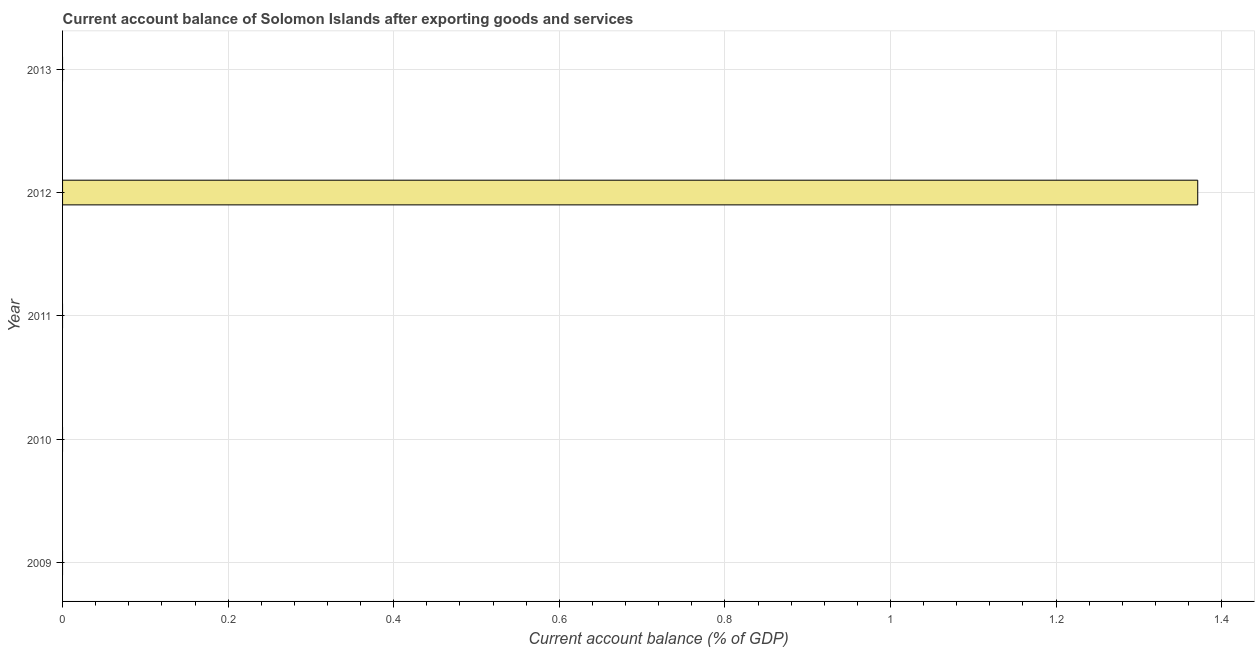Does the graph contain any zero values?
Provide a short and direct response. Yes. Does the graph contain grids?
Provide a succinct answer. Yes. What is the title of the graph?
Provide a short and direct response. Current account balance of Solomon Islands after exporting goods and services. What is the label or title of the X-axis?
Provide a short and direct response. Current account balance (% of GDP). Across all years, what is the maximum current account balance?
Offer a very short reply. 1.37. Across all years, what is the minimum current account balance?
Give a very brief answer. 0. What is the sum of the current account balance?
Your answer should be very brief. 1.37. What is the average current account balance per year?
Your answer should be very brief. 0.27. What is the difference between the highest and the lowest current account balance?
Give a very brief answer. 1.37. In how many years, is the current account balance greater than the average current account balance taken over all years?
Your answer should be compact. 1. How many bars are there?
Offer a terse response. 1. How many years are there in the graph?
Offer a very short reply. 5. What is the difference between two consecutive major ticks on the X-axis?
Offer a terse response. 0.2. What is the Current account balance (% of GDP) in 2009?
Offer a very short reply. 0. What is the Current account balance (% of GDP) in 2012?
Keep it short and to the point. 1.37. 